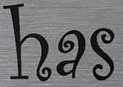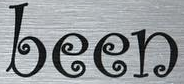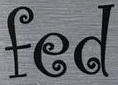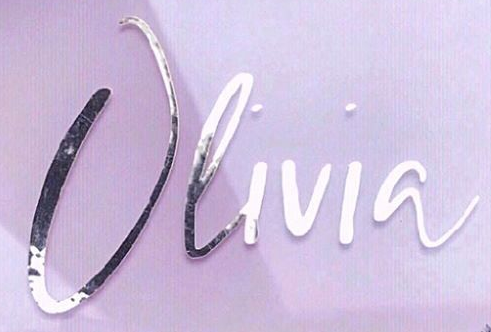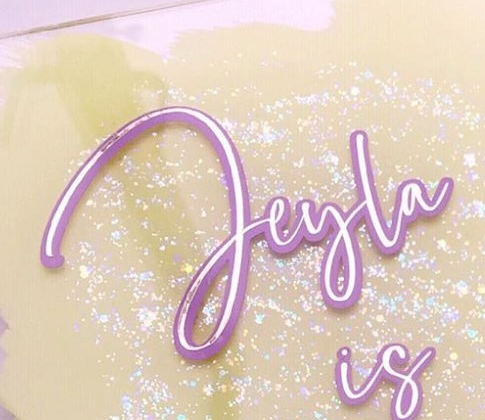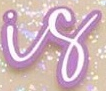Transcribe the words shown in these images in order, separated by a semicolon. has; been; fed; Olivia; Jeyla; is 